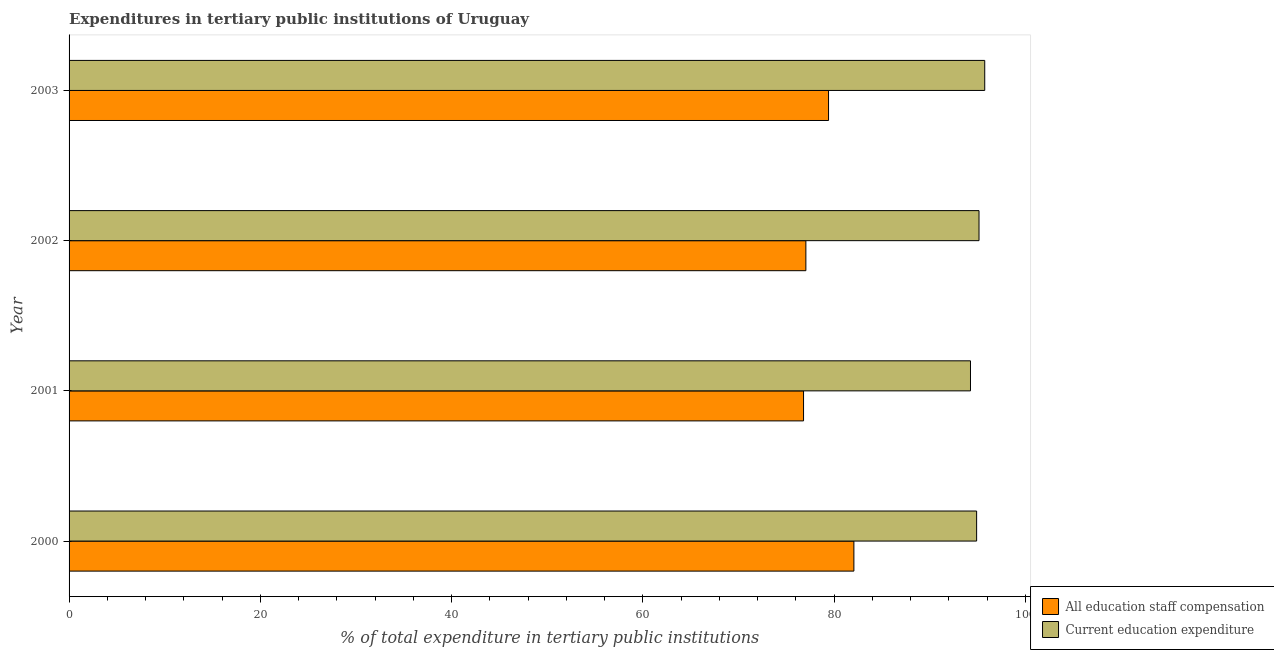In how many cases, is the number of bars for a given year not equal to the number of legend labels?
Give a very brief answer. 0. What is the expenditure in staff compensation in 2000?
Make the answer very short. 82.07. Across all years, what is the maximum expenditure in education?
Provide a succinct answer. 95.75. Across all years, what is the minimum expenditure in education?
Offer a terse response. 94.26. In which year was the expenditure in education maximum?
Provide a short and direct response. 2003. In which year was the expenditure in education minimum?
Your answer should be very brief. 2001. What is the total expenditure in education in the graph?
Give a very brief answer. 380.06. What is the difference between the expenditure in staff compensation in 2000 and that in 2003?
Ensure brevity in your answer.  2.65. What is the difference between the expenditure in staff compensation in 2002 and the expenditure in education in 2001?
Provide a succinct answer. -17.21. What is the average expenditure in education per year?
Provide a short and direct response. 95.02. In the year 2002, what is the difference between the expenditure in education and expenditure in staff compensation?
Provide a succinct answer. 18.11. What is the ratio of the expenditure in education in 2001 to that in 2003?
Offer a very short reply. 0.98. Is the expenditure in education in 2000 less than that in 2002?
Provide a succinct answer. Yes. Is the difference between the expenditure in education in 2001 and 2003 greater than the difference between the expenditure in staff compensation in 2001 and 2003?
Give a very brief answer. Yes. What is the difference between the highest and the second highest expenditure in education?
Ensure brevity in your answer.  0.6. What is the difference between the highest and the lowest expenditure in education?
Give a very brief answer. 1.49. In how many years, is the expenditure in education greater than the average expenditure in education taken over all years?
Offer a terse response. 2. What does the 2nd bar from the top in 2002 represents?
Your answer should be compact. All education staff compensation. What does the 1st bar from the bottom in 2002 represents?
Offer a terse response. All education staff compensation. How many bars are there?
Ensure brevity in your answer.  8. Are all the bars in the graph horizontal?
Offer a terse response. Yes. Does the graph contain grids?
Give a very brief answer. No. Where does the legend appear in the graph?
Make the answer very short. Bottom right. How are the legend labels stacked?
Provide a succinct answer. Vertical. What is the title of the graph?
Offer a very short reply. Expenditures in tertiary public institutions of Uruguay. What is the label or title of the X-axis?
Offer a very short reply. % of total expenditure in tertiary public institutions. What is the % of total expenditure in tertiary public institutions of All education staff compensation in 2000?
Give a very brief answer. 82.07. What is the % of total expenditure in tertiary public institutions of Current education expenditure in 2000?
Your answer should be very brief. 94.9. What is the % of total expenditure in tertiary public institutions in All education staff compensation in 2001?
Provide a succinct answer. 76.8. What is the % of total expenditure in tertiary public institutions in Current education expenditure in 2001?
Your answer should be compact. 94.26. What is the % of total expenditure in tertiary public institutions in All education staff compensation in 2002?
Provide a short and direct response. 77.05. What is the % of total expenditure in tertiary public institutions in Current education expenditure in 2002?
Offer a terse response. 95.15. What is the % of total expenditure in tertiary public institutions in All education staff compensation in 2003?
Your answer should be very brief. 79.42. What is the % of total expenditure in tertiary public institutions of Current education expenditure in 2003?
Offer a very short reply. 95.75. Across all years, what is the maximum % of total expenditure in tertiary public institutions in All education staff compensation?
Your answer should be very brief. 82.07. Across all years, what is the maximum % of total expenditure in tertiary public institutions in Current education expenditure?
Ensure brevity in your answer.  95.75. Across all years, what is the minimum % of total expenditure in tertiary public institutions of All education staff compensation?
Give a very brief answer. 76.8. Across all years, what is the minimum % of total expenditure in tertiary public institutions in Current education expenditure?
Provide a succinct answer. 94.26. What is the total % of total expenditure in tertiary public institutions in All education staff compensation in the graph?
Your answer should be very brief. 315.33. What is the total % of total expenditure in tertiary public institutions of Current education expenditure in the graph?
Make the answer very short. 380.06. What is the difference between the % of total expenditure in tertiary public institutions of All education staff compensation in 2000 and that in 2001?
Your answer should be very brief. 5.27. What is the difference between the % of total expenditure in tertiary public institutions in Current education expenditure in 2000 and that in 2001?
Provide a succinct answer. 0.64. What is the difference between the % of total expenditure in tertiary public institutions of All education staff compensation in 2000 and that in 2002?
Offer a terse response. 5.02. What is the difference between the % of total expenditure in tertiary public institutions of Current education expenditure in 2000 and that in 2002?
Your answer should be very brief. -0.25. What is the difference between the % of total expenditure in tertiary public institutions in All education staff compensation in 2000 and that in 2003?
Your response must be concise. 2.65. What is the difference between the % of total expenditure in tertiary public institutions of Current education expenditure in 2000 and that in 2003?
Offer a very short reply. -0.85. What is the difference between the % of total expenditure in tertiary public institutions of All education staff compensation in 2001 and that in 2002?
Your answer should be very brief. -0.24. What is the difference between the % of total expenditure in tertiary public institutions in Current education expenditure in 2001 and that in 2002?
Your response must be concise. -0.89. What is the difference between the % of total expenditure in tertiary public institutions in All education staff compensation in 2001 and that in 2003?
Make the answer very short. -2.61. What is the difference between the % of total expenditure in tertiary public institutions in Current education expenditure in 2001 and that in 2003?
Your answer should be very brief. -1.49. What is the difference between the % of total expenditure in tertiary public institutions of All education staff compensation in 2002 and that in 2003?
Ensure brevity in your answer.  -2.37. What is the difference between the % of total expenditure in tertiary public institutions of Current education expenditure in 2002 and that in 2003?
Ensure brevity in your answer.  -0.6. What is the difference between the % of total expenditure in tertiary public institutions of All education staff compensation in 2000 and the % of total expenditure in tertiary public institutions of Current education expenditure in 2001?
Make the answer very short. -12.19. What is the difference between the % of total expenditure in tertiary public institutions of All education staff compensation in 2000 and the % of total expenditure in tertiary public institutions of Current education expenditure in 2002?
Ensure brevity in your answer.  -13.08. What is the difference between the % of total expenditure in tertiary public institutions of All education staff compensation in 2000 and the % of total expenditure in tertiary public institutions of Current education expenditure in 2003?
Your answer should be compact. -13.68. What is the difference between the % of total expenditure in tertiary public institutions in All education staff compensation in 2001 and the % of total expenditure in tertiary public institutions in Current education expenditure in 2002?
Your answer should be compact. -18.35. What is the difference between the % of total expenditure in tertiary public institutions of All education staff compensation in 2001 and the % of total expenditure in tertiary public institutions of Current education expenditure in 2003?
Provide a short and direct response. -18.95. What is the difference between the % of total expenditure in tertiary public institutions in All education staff compensation in 2002 and the % of total expenditure in tertiary public institutions in Current education expenditure in 2003?
Your response must be concise. -18.7. What is the average % of total expenditure in tertiary public institutions in All education staff compensation per year?
Make the answer very short. 78.83. What is the average % of total expenditure in tertiary public institutions in Current education expenditure per year?
Your answer should be very brief. 95.02. In the year 2000, what is the difference between the % of total expenditure in tertiary public institutions in All education staff compensation and % of total expenditure in tertiary public institutions in Current education expenditure?
Your response must be concise. -12.83. In the year 2001, what is the difference between the % of total expenditure in tertiary public institutions in All education staff compensation and % of total expenditure in tertiary public institutions in Current education expenditure?
Make the answer very short. -17.46. In the year 2002, what is the difference between the % of total expenditure in tertiary public institutions in All education staff compensation and % of total expenditure in tertiary public institutions in Current education expenditure?
Make the answer very short. -18.11. In the year 2003, what is the difference between the % of total expenditure in tertiary public institutions of All education staff compensation and % of total expenditure in tertiary public institutions of Current education expenditure?
Your response must be concise. -16.33. What is the ratio of the % of total expenditure in tertiary public institutions in All education staff compensation in 2000 to that in 2001?
Make the answer very short. 1.07. What is the ratio of the % of total expenditure in tertiary public institutions of Current education expenditure in 2000 to that in 2001?
Your answer should be compact. 1.01. What is the ratio of the % of total expenditure in tertiary public institutions of All education staff compensation in 2000 to that in 2002?
Give a very brief answer. 1.07. What is the ratio of the % of total expenditure in tertiary public institutions in Current education expenditure in 2000 to that in 2002?
Your response must be concise. 1. What is the ratio of the % of total expenditure in tertiary public institutions of All education staff compensation in 2000 to that in 2003?
Provide a succinct answer. 1.03. What is the ratio of the % of total expenditure in tertiary public institutions in Current education expenditure in 2001 to that in 2002?
Provide a short and direct response. 0.99. What is the ratio of the % of total expenditure in tertiary public institutions of All education staff compensation in 2001 to that in 2003?
Provide a short and direct response. 0.97. What is the ratio of the % of total expenditure in tertiary public institutions in Current education expenditure in 2001 to that in 2003?
Your response must be concise. 0.98. What is the ratio of the % of total expenditure in tertiary public institutions in All education staff compensation in 2002 to that in 2003?
Provide a succinct answer. 0.97. What is the ratio of the % of total expenditure in tertiary public institutions of Current education expenditure in 2002 to that in 2003?
Give a very brief answer. 0.99. What is the difference between the highest and the second highest % of total expenditure in tertiary public institutions of All education staff compensation?
Your answer should be very brief. 2.65. What is the difference between the highest and the second highest % of total expenditure in tertiary public institutions of Current education expenditure?
Provide a succinct answer. 0.6. What is the difference between the highest and the lowest % of total expenditure in tertiary public institutions in All education staff compensation?
Provide a succinct answer. 5.27. What is the difference between the highest and the lowest % of total expenditure in tertiary public institutions in Current education expenditure?
Keep it short and to the point. 1.49. 